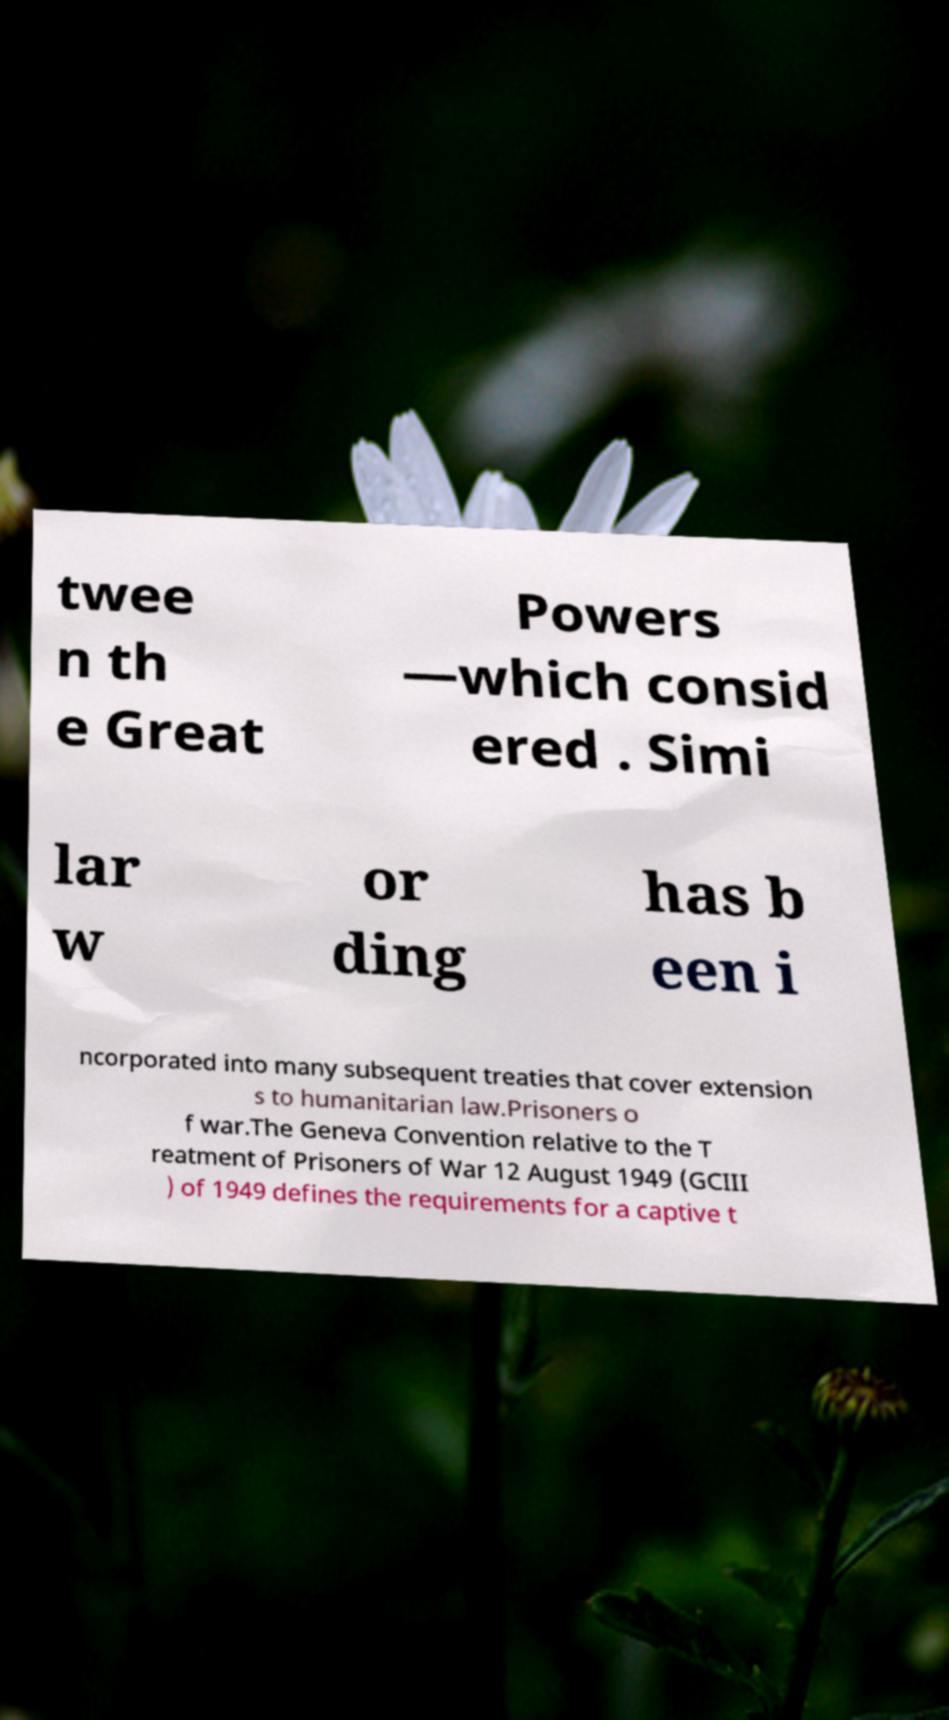Can you accurately transcribe the text from the provided image for me? twee n th e Great Powers —which consid ered . Simi lar w or ding has b een i ncorporated into many subsequent treaties that cover extension s to humanitarian law.Prisoners o f war.The Geneva Convention relative to the T reatment of Prisoners of War 12 August 1949 (GCIII ) of 1949 defines the requirements for a captive t 